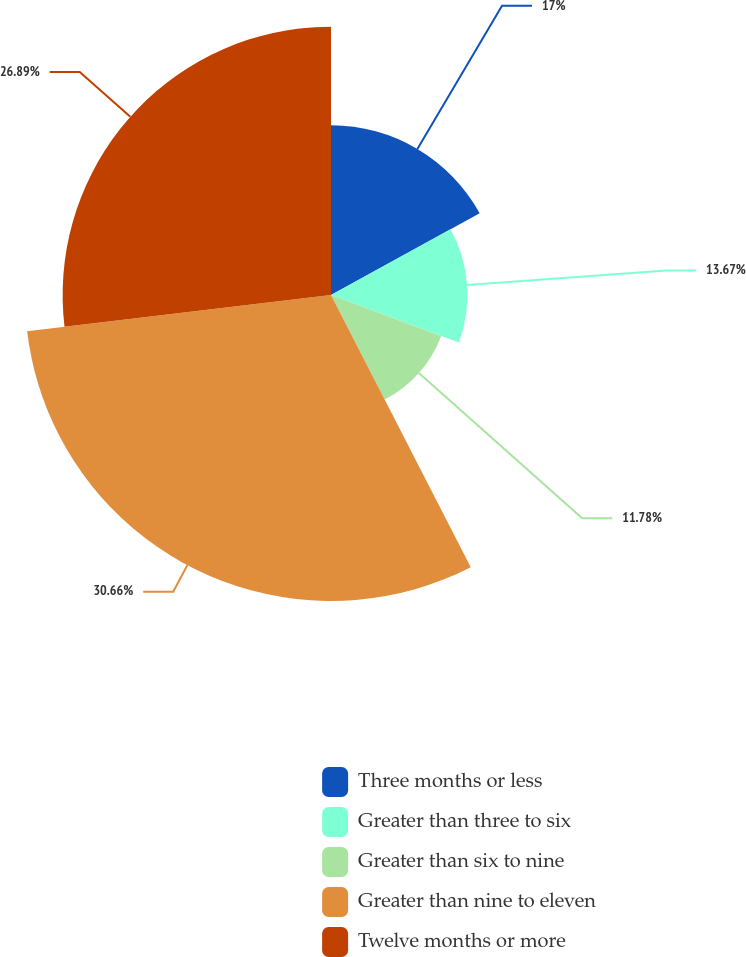Convert chart to OTSL. <chart><loc_0><loc_0><loc_500><loc_500><pie_chart><fcel>Three months or less<fcel>Greater than three to six<fcel>Greater than six to nine<fcel>Greater than nine to eleven<fcel>Twelve months or more<nl><fcel>17.0%<fcel>13.67%<fcel>11.78%<fcel>30.66%<fcel>26.89%<nl></chart> 